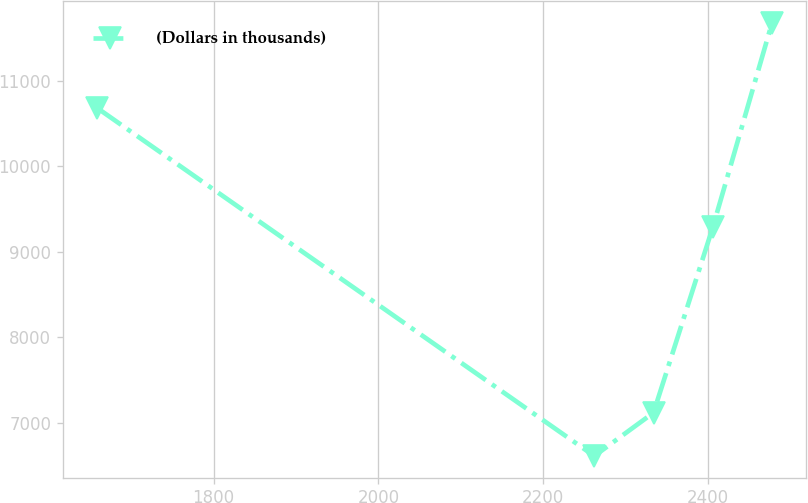Convert chart. <chart><loc_0><loc_0><loc_500><loc_500><line_chart><ecel><fcel>(Dollars in thousands)<nl><fcel>1658.05<fcel>10684.7<nl><fcel>2262.06<fcel>6613.09<nl><fcel>2333.97<fcel>7119.33<nl><fcel>2405.88<fcel>9285.26<nl><fcel>2477.79<fcel>11675.5<nl></chart> 